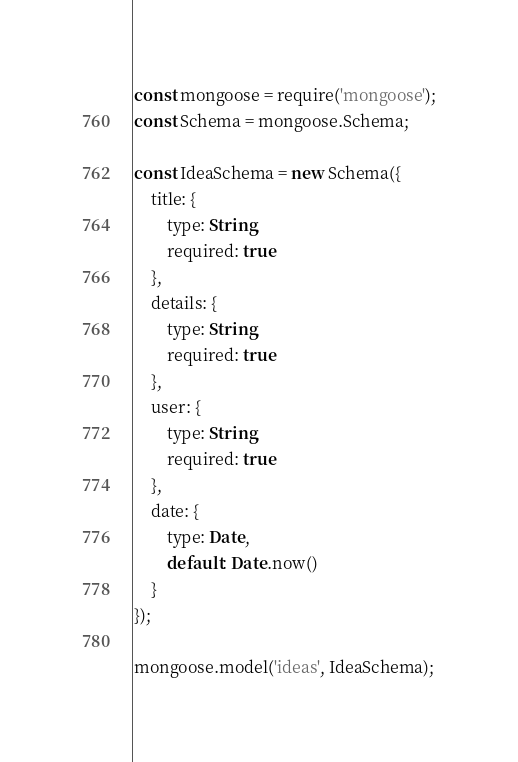<code> <loc_0><loc_0><loc_500><loc_500><_JavaScript_>const mongoose = require('mongoose');
const Schema = mongoose.Schema;

const IdeaSchema = new Schema({
    title: {
        type: String,
        required: true
    },
    details: {
        type: String,
        required: true
    },
    user: {
        type: String,
        required: true
    },
    date: {
        type: Date,
        default: Date.now()
    }
});

mongoose.model('ideas', IdeaSchema);</code> 